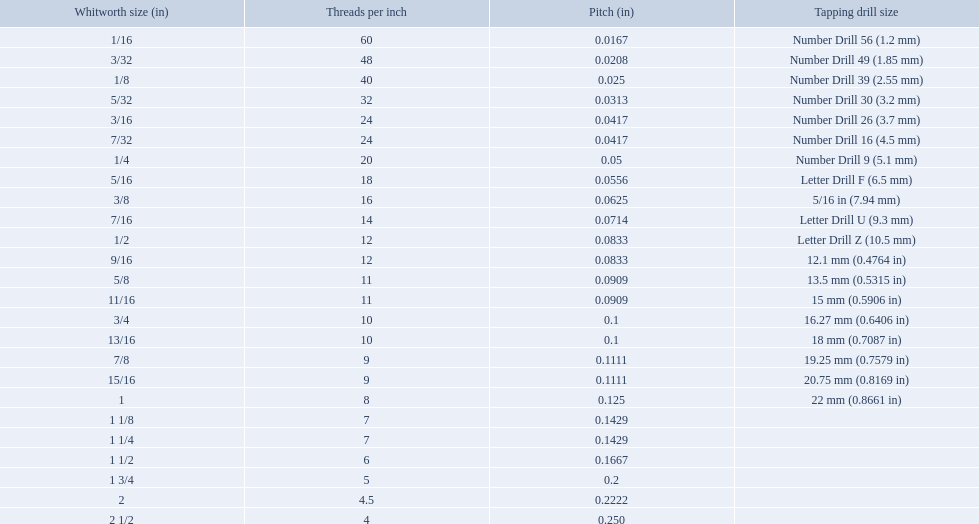What are all of the whitworth sizes? 1/16, 3/32, 1/8, 5/32, 3/16, 7/32, 1/4, 5/16, 3/8, 7/16, 1/2, 9/16, 5/8, 11/16, 3/4, 13/16, 7/8, 15/16, 1, 1 1/8, 1 1/4, 1 1/2, 1 3/4, 2, 2 1/2. How many threads per inch are in each size? 60, 48, 40, 32, 24, 24, 20, 18, 16, 14, 12, 12, 11, 11, 10, 10, 9, 9, 8, 7, 7, 6, 5, 4.5, 4. How many threads per inch are in the 3/16 size? 24. And which other size has the same number of threads? 7/32. What are the sizes of threads per inch? 60, 48, 40, 32, 24, 24, 20, 18, 16, 14, 12, 12, 11, 11, 10, 10, 9, 9, 8, 7, 7, 6, 5, 4.5, 4. Which whitworth size has only 5 threads per inch? 1 3/4. What are all of the whitworth sizes in the british standard whitworth? 1/16, 3/32, 1/8, 5/32, 3/16, 7/32, 1/4, 5/16, 3/8, 7/16, 1/2, 9/16, 5/8, 11/16, 3/4, 13/16, 7/8, 15/16, 1, 1 1/8, 1 1/4, 1 1/2, 1 3/4, 2, 2 1/2. Which of these sizes uses a tapping drill size of 26? 3/16. What is the core diameter for the number drill 26? 0.1341. What is the whitworth size (in) for this core diameter? 3/16. 